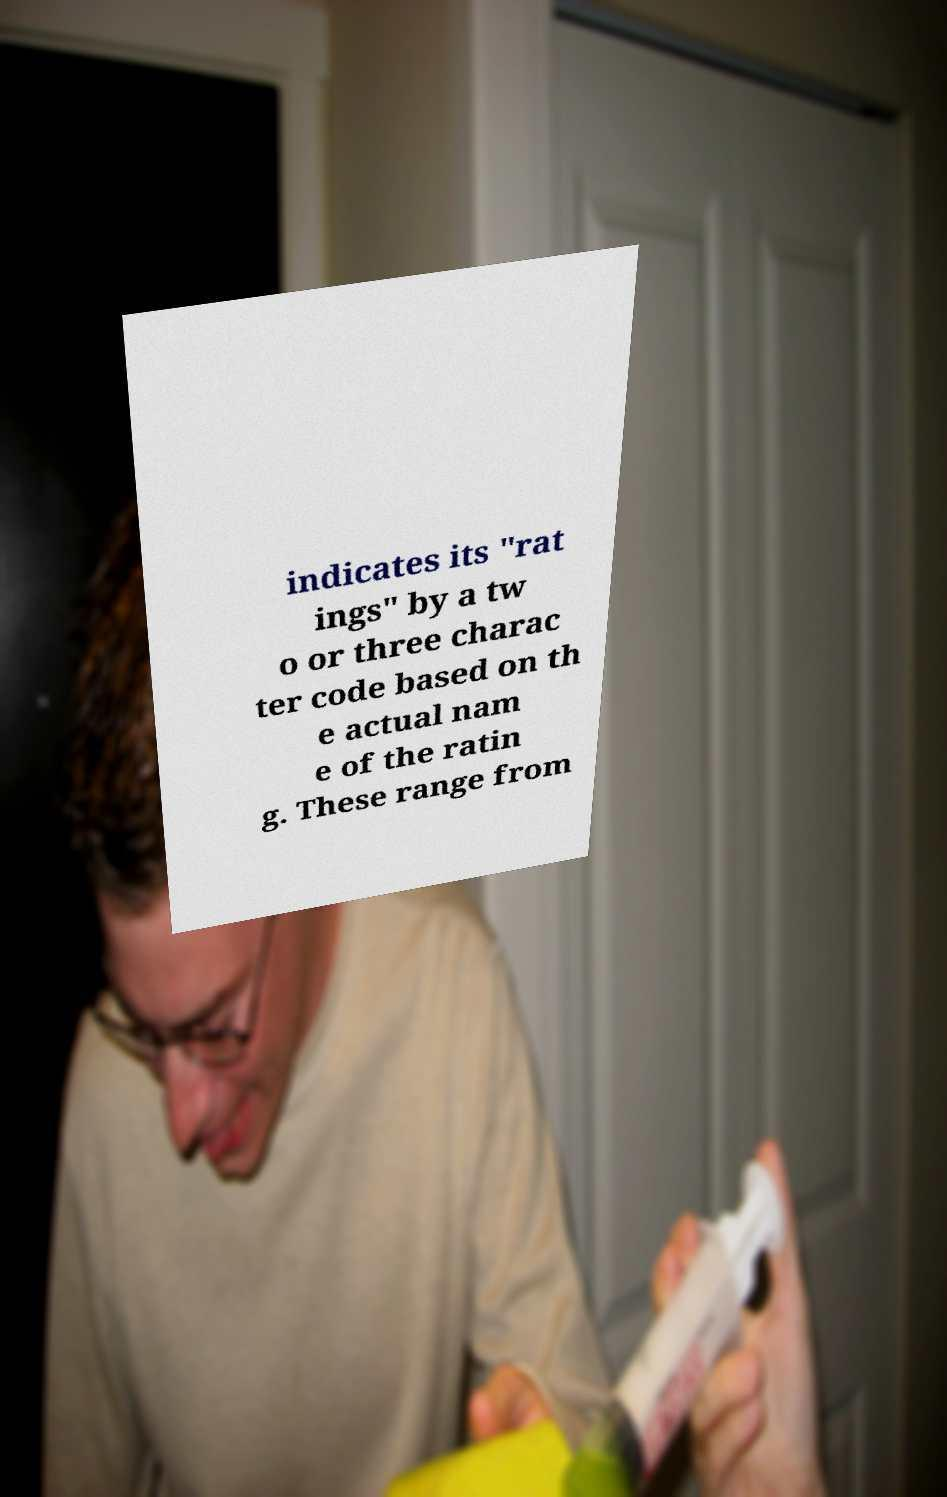Can you read and provide the text displayed in the image?This photo seems to have some interesting text. Can you extract and type it out for me? indicates its "rat ings" by a tw o or three charac ter code based on th e actual nam e of the ratin g. These range from 